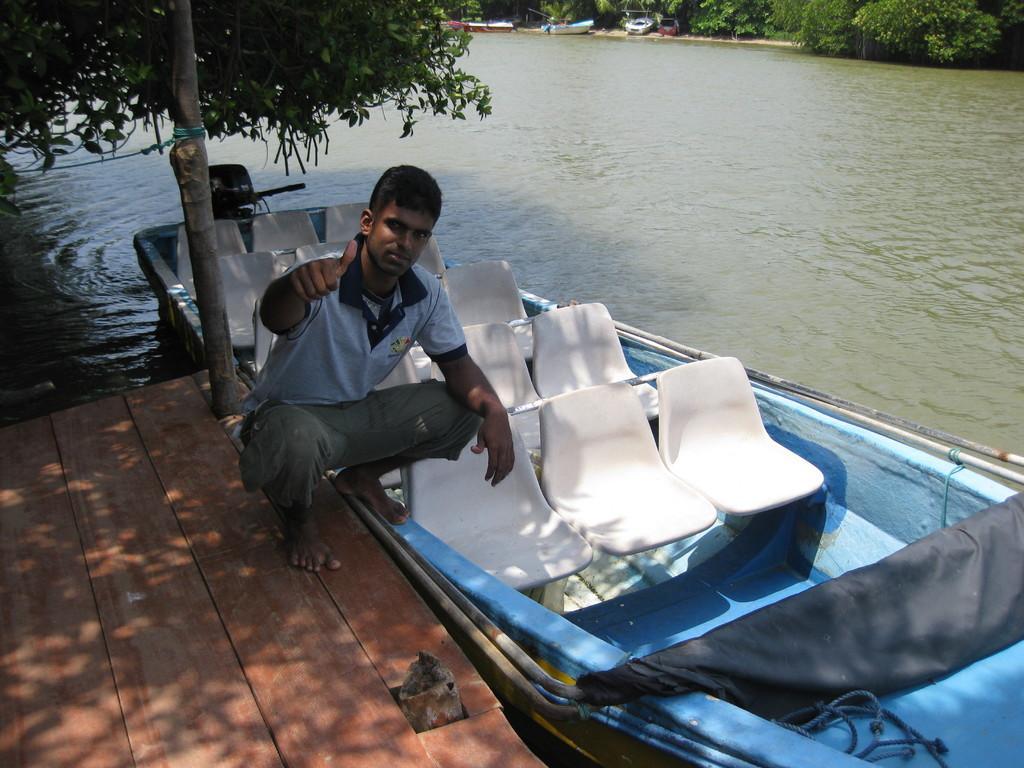Describe this image in one or two sentences. In this picture, we can see a person on wooden path, we can see a boat, water, trees, ground, and a few vehicles. 